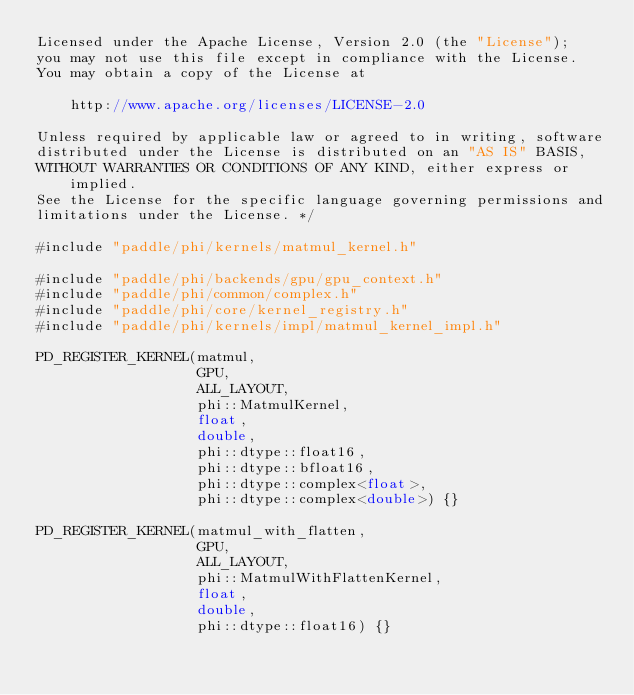<code> <loc_0><loc_0><loc_500><loc_500><_Cuda_>Licensed under the Apache License, Version 2.0 (the "License");
you may not use this file except in compliance with the License.
You may obtain a copy of the License at

    http://www.apache.org/licenses/LICENSE-2.0

Unless required by applicable law or agreed to in writing, software
distributed under the License is distributed on an "AS IS" BASIS,
WITHOUT WARRANTIES OR CONDITIONS OF ANY KIND, either express or implied.
See the License for the specific language governing permissions and
limitations under the License. */

#include "paddle/phi/kernels/matmul_kernel.h"

#include "paddle/phi/backends/gpu/gpu_context.h"
#include "paddle/phi/common/complex.h"
#include "paddle/phi/core/kernel_registry.h"
#include "paddle/phi/kernels/impl/matmul_kernel_impl.h"

PD_REGISTER_KERNEL(matmul,
                   GPU,
                   ALL_LAYOUT,
                   phi::MatmulKernel,
                   float,
                   double,
                   phi::dtype::float16,
                   phi::dtype::bfloat16,
                   phi::dtype::complex<float>,
                   phi::dtype::complex<double>) {}

PD_REGISTER_KERNEL(matmul_with_flatten,
                   GPU,
                   ALL_LAYOUT,
                   phi::MatmulWithFlattenKernel,
                   float,
                   double,
                   phi::dtype::float16) {}
</code> 